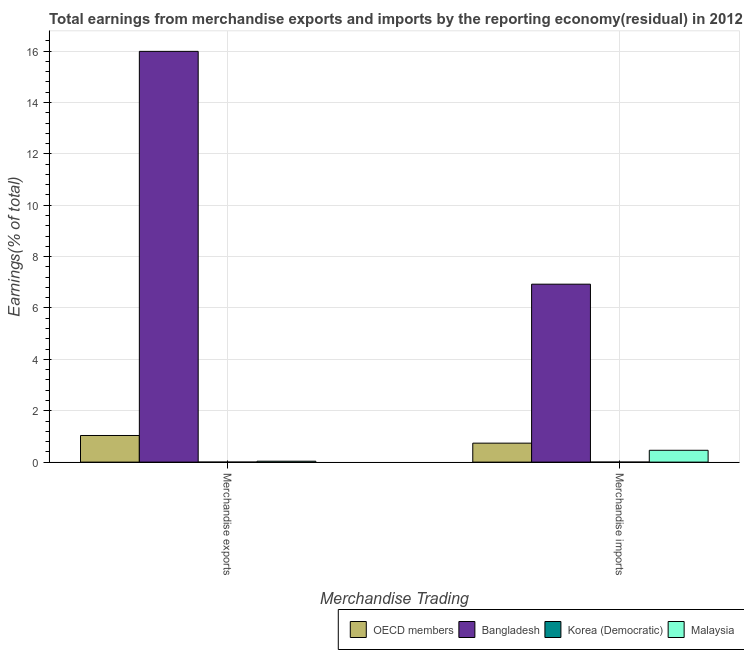How many different coloured bars are there?
Your answer should be very brief. 4. How many groups of bars are there?
Your answer should be very brief. 2. How many bars are there on the 2nd tick from the right?
Provide a succinct answer. 4. What is the earnings from merchandise imports in OECD members?
Provide a short and direct response. 0.74. Across all countries, what is the maximum earnings from merchandise imports?
Give a very brief answer. 6.93. Across all countries, what is the minimum earnings from merchandise exports?
Make the answer very short. 7.84132135436542e-9. In which country was the earnings from merchandise imports maximum?
Provide a succinct answer. Bangladesh. In which country was the earnings from merchandise imports minimum?
Offer a very short reply. Korea (Democratic). What is the total earnings from merchandise imports in the graph?
Provide a succinct answer. 8.13. What is the difference between the earnings from merchandise exports in Malaysia and that in OECD members?
Provide a short and direct response. -1. What is the difference between the earnings from merchandise exports in Korea (Democratic) and the earnings from merchandise imports in Malaysia?
Your answer should be compact. -0.46. What is the average earnings from merchandise exports per country?
Your answer should be compact. 4.27. What is the difference between the earnings from merchandise exports and earnings from merchandise imports in Korea (Democratic)?
Your answer should be very brief. 4.1745547392387e-9. What is the ratio of the earnings from merchandise exports in OECD members to that in Korea (Democratic)?
Provide a short and direct response. 1.32e+08. Is the earnings from merchandise exports in Bangladesh less than that in Malaysia?
Your response must be concise. No. What does the 3rd bar from the left in Merchandise imports represents?
Your answer should be compact. Korea (Democratic). What does the 4th bar from the right in Merchandise exports represents?
Give a very brief answer. OECD members. Are all the bars in the graph horizontal?
Give a very brief answer. No. Are the values on the major ticks of Y-axis written in scientific E-notation?
Offer a terse response. No. Where does the legend appear in the graph?
Keep it short and to the point. Bottom right. What is the title of the graph?
Your answer should be very brief. Total earnings from merchandise exports and imports by the reporting economy(residual) in 2012. What is the label or title of the X-axis?
Provide a short and direct response. Merchandise Trading. What is the label or title of the Y-axis?
Your answer should be very brief. Earnings(% of total). What is the Earnings(% of total) in OECD members in Merchandise exports?
Keep it short and to the point. 1.04. What is the Earnings(% of total) of Bangladesh in Merchandise exports?
Provide a succinct answer. 15.99. What is the Earnings(% of total) in Korea (Democratic) in Merchandise exports?
Your response must be concise. 7.84132135436542e-9. What is the Earnings(% of total) in Malaysia in Merchandise exports?
Give a very brief answer. 0.04. What is the Earnings(% of total) in OECD members in Merchandise imports?
Make the answer very short. 0.74. What is the Earnings(% of total) of Bangladesh in Merchandise imports?
Ensure brevity in your answer.  6.93. What is the Earnings(% of total) of Korea (Democratic) in Merchandise imports?
Your response must be concise. 3.666766615126721e-9. What is the Earnings(% of total) of Malaysia in Merchandise imports?
Offer a very short reply. 0.46. Across all Merchandise Trading, what is the maximum Earnings(% of total) in OECD members?
Provide a succinct answer. 1.04. Across all Merchandise Trading, what is the maximum Earnings(% of total) in Bangladesh?
Your answer should be compact. 15.99. Across all Merchandise Trading, what is the maximum Earnings(% of total) of Korea (Democratic)?
Offer a very short reply. 7.84132135436542e-9. Across all Merchandise Trading, what is the maximum Earnings(% of total) in Malaysia?
Your answer should be very brief. 0.46. Across all Merchandise Trading, what is the minimum Earnings(% of total) in OECD members?
Your response must be concise. 0.74. Across all Merchandise Trading, what is the minimum Earnings(% of total) in Bangladesh?
Your answer should be very brief. 6.93. Across all Merchandise Trading, what is the minimum Earnings(% of total) of Korea (Democratic)?
Your answer should be very brief. 3.666766615126721e-9. Across all Merchandise Trading, what is the minimum Earnings(% of total) in Malaysia?
Provide a short and direct response. 0.04. What is the total Earnings(% of total) in OECD members in the graph?
Keep it short and to the point. 1.78. What is the total Earnings(% of total) in Bangladesh in the graph?
Your response must be concise. 22.92. What is the total Earnings(% of total) in Korea (Democratic) in the graph?
Ensure brevity in your answer.  0. What is the total Earnings(% of total) in Malaysia in the graph?
Your response must be concise. 0.5. What is the difference between the Earnings(% of total) of OECD members in Merchandise exports and that in Merchandise imports?
Your answer should be very brief. 0.3. What is the difference between the Earnings(% of total) of Bangladesh in Merchandise exports and that in Merchandise imports?
Your answer should be very brief. 9.06. What is the difference between the Earnings(% of total) in Korea (Democratic) in Merchandise exports and that in Merchandise imports?
Offer a terse response. 0. What is the difference between the Earnings(% of total) in Malaysia in Merchandise exports and that in Merchandise imports?
Offer a terse response. -0.42. What is the difference between the Earnings(% of total) in OECD members in Merchandise exports and the Earnings(% of total) in Bangladesh in Merchandise imports?
Your response must be concise. -5.89. What is the difference between the Earnings(% of total) of OECD members in Merchandise exports and the Earnings(% of total) of Korea (Democratic) in Merchandise imports?
Your answer should be very brief. 1.04. What is the difference between the Earnings(% of total) in OECD members in Merchandise exports and the Earnings(% of total) in Malaysia in Merchandise imports?
Provide a succinct answer. 0.58. What is the difference between the Earnings(% of total) of Bangladesh in Merchandise exports and the Earnings(% of total) of Korea (Democratic) in Merchandise imports?
Give a very brief answer. 15.99. What is the difference between the Earnings(% of total) in Bangladesh in Merchandise exports and the Earnings(% of total) in Malaysia in Merchandise imports?
Ensure brevity in your answer.  15.53. What is the difference between the Earnings(% of total) in Korea (Democratic) in Merchandise exports and the Earnings(% of total) in Malaysia in Merchandise imports?
Your answer should be compact. -0.46. What is the average Earnings(% of total) of OECD members per Merchandise Trading?
Provide a short and direct response. 0.89. What is the average Earnings(% of total) of Bangladesh per Merchandise Trading?
Provide a succinct answer. 11.46. What is the average Earnings(% of total) in Korea (Democratic) per Merchandise Trading?
Keep it short and to the point. 0. What is the average Earnings(% of total) in Malaysia per Merchandise Trading?
Your answer should be very brief. 0.25. What is the difference between the Earnings(% of total) of OECD members and Earnings(% of total) of Bangladesh in Merchandise exports?
Give a very brief answer. -14.95. What is the difference between the Earnings(% of total) in OECD members and Earnings(% of total) in Korea (Democratic) in Merchandise exports?
Keep it short and to the point. 1.04. What is the difference between the Earnings(% of total) of Bangladesh and Earnings(% of total) of Korea (Democratic) in Merchandise exports?
Your answer should be very brief. 15.99. What is the difference between the Earnings(% of total) in Bangladesh and Earnings(% of total) in Malaysia in Merchandise exports?
Make the answer very short. 15.95. What is the difference between the Earnings(% of total) of Korea (Democratic) and Earnings(% of total) of Malaysia in Merchandise exports?
Provide a succinct answer. -0.04. What is the difference between the Earnings(% of total) in OECD members and Earnings(% of total) in Bangladesh in Merchandise imports?
Provide a short and direct response. -6.19. What is the difference between the Earnings(% of total) of OECD members and Earnings(% of total) of Korea (Democratic) in Merchandise imports?
Offer a very short reply. 0.74. What is the difference between the Earnings(% of total) of OECD members and Earnings(% of total) of Malaysia in Merchandise imports?
Provide a succinct answer. 0.28. What is the difference between the Earnings(% of total) of Bangladesh and Earnings(% of total) of Korea (Democratic) in Merchandise imports?
Offer a very short reply. 6.93. What is the difference between the Earnings(% of total) in Bangladesh and Earnings(% of total) in Malaysia in Merchandise imports?
Your answer should be compact. 6.47. What is the difference between the Earnings(% of total) of Korea (Democratic) and Earnings(% of total) of Malaysia in Merchandise imports?
Your response must be concise. -0.46. What is the ratio of the Earnings(% of total) in OECD members in Merchandise exports to that in Merchandise imports?
Provide a succinct answer. 1.4. What is the ratio of the Earnings(% of total) of Bangladesh in Merchandise exports to that in Merchandise imports?
Your answer should be very brief. 2.31. What is the ratio of the Earnings(% of total) of Korea (Democratic) in Merchandise exports to that in Merchandise imports?
Your response must be concise. 2.14. What is the ratio of the Earnings(% of total) in Malaysia in Merchandise exports to that in Merchandise imports?
Ensure brevity in your answer.  0.08. What is the difference between the highest and the second highest Earnings(% of total) of OECD members?
Your response must be concise. 0.3. What is the difference between the highest and the second highest Earnings(% of total) of Bangladesh?
Your answer should be compact. 9.06. What is the difference between the highest and the second highest Earnings(% of total) in Korea (Democratic)?
Your answer should be compact. 0. What is the difference between the highest and the second highest Earnings(% of total) in Malaysia?
Your answer should be very brief. 0.42. What is the difference between the highest and the lowest Earnings(% of total) of OECD members?
Your answer should be very brief. 0.3. What is the difference between the highest and the lowest Earnings(% of total) of Bangladesh?
Offer a terse response. 9.06. What is the difference between the highest and the lowest Earnings(% of total) of Korea (Democratic)?
Provide a short and direct response. 0. What is the difference between the highest and the lowest Earnings(% of total) in Malaysia?
Keep it short and to the point. 0.42. 